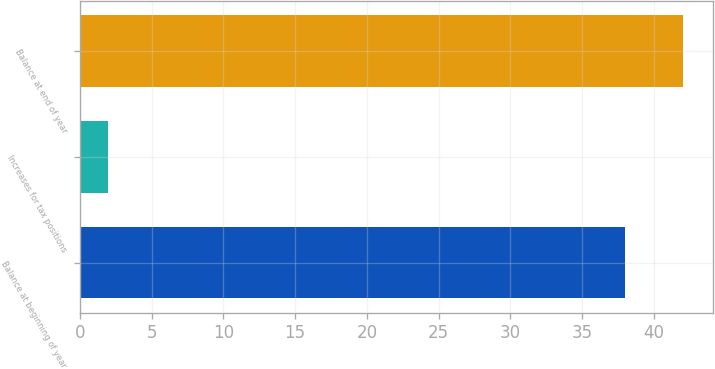Convert chart. <chart><loc_0><loc_0><loc_500><loc_500><bar_chart><fcel>Balance at beginning of year<fcel>Increases for tax positions<fcel>Balance at end of year<nl><fcel>38<fcel>2<fcel>42<nl></chart> 